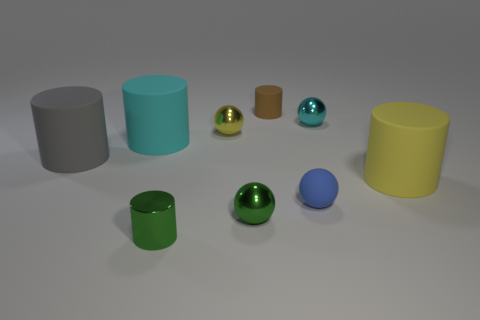There is a yellow thing that is left of the small rubber ball; how many shiny objects are in front of it?
Make the answer very short. 2. The object that is right of the tiny blue rubber sphere and behind the large cyan object is made of what material?
Provide a succinct answer. Metal. The cyan thing that is the same size as the blue object is what shape?
Offer a terse response. Sphere. What color is the matte object to the right of the shiny thing that is right of the small object behind the small cyan thing?
Provide a succinct answer. Yellow. What number of things are either things to the right of the big cyan cylinder or green objects?
Your answer should be very brief. 7. There is a blue sphere that is the same size as the cyan metal ball; what is it made of?
Offer a very short reply. Rubber. What material is the cyan thing that is on the right side of the metal ball in front of the large matte object on the right side of the yellow shiny object made of?
Your answer should be compact. Metal. What is the color of the matte ball?
Provide a succinct answer. Blue. How many tiny things are either green spheres or gray cylinders?
Ensure brevity in your answer.  1. What is the material of the small sphere that is the same color as the small metallic cylinder?
Your response must be concise. Metal. 